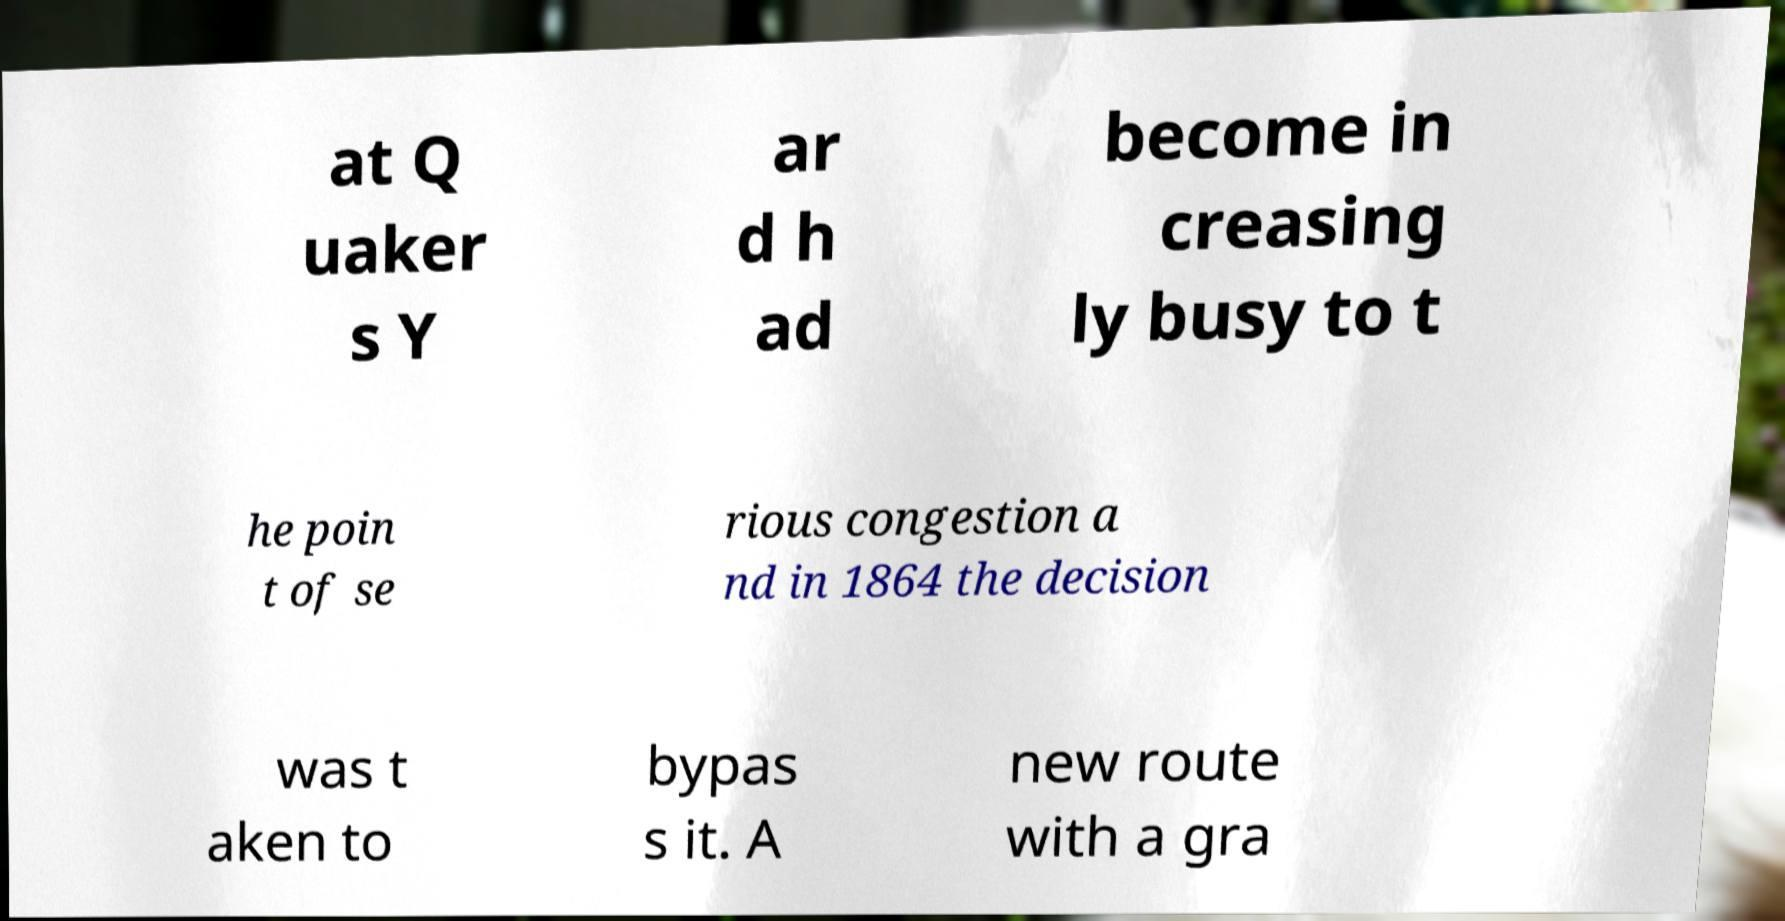Can you accurately transcribe the text from the provided image for me? at Q uaker s Y ar d h ad become in creasing ly busy to t he poin t of se rious congestion a nd in 1864 the decision was t aken to bypas s it. A new route with a gra 